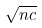<formula> <loc_0><loc_0><loc_500><loc_500>\sqrt { n c }</formula> 